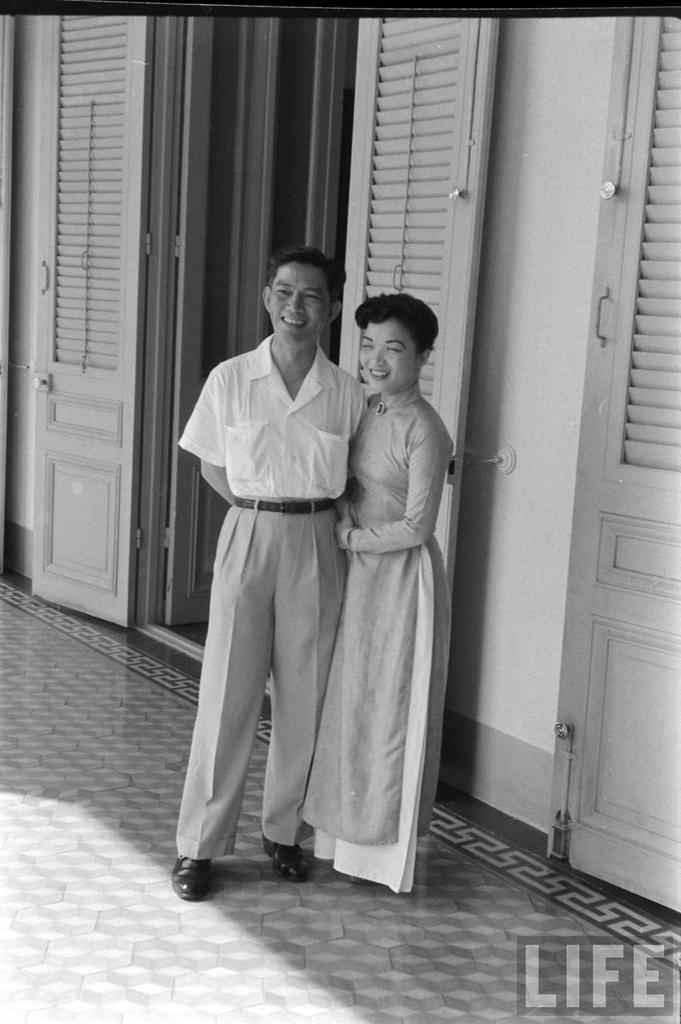What is the primary surface visible in the image? There is a floor in the image. How many people are present in the image? There are two people standing in the image. What is located behind the people? There is a door behind the people. What type of architectural feature is present in the image? There is a wall in the image. What type of cherry can be smelled in the image? There is no cherry present in the image, and therefore no scent can be detected. Is there a notebook visible on the wall in the image? There is no notebook visible on the wall in the image. 